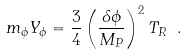Convert formula to latex. <formula><loc_0><loc_0><loc_500><loc_500>m _ { \phi } Y _ { \phi } = \frac { 3 } { 4 } \left ( \frac { \delta \phi } { M _ { P } } \right ) ^ { 2 } T _ { R } \ .</formula> 